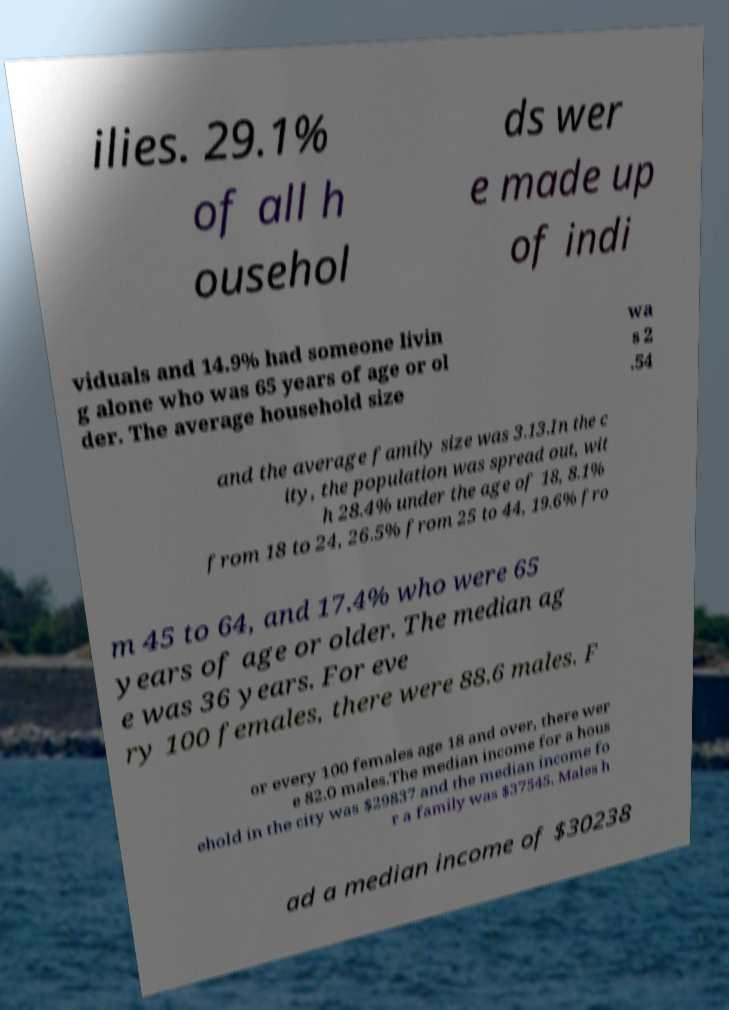What messages or text are displayed in this image? I need them in a readable, typed format. ilies. 29.1% of all h ousehol ds wer e made up of indi viduals and 14.9% had someone livin g alone who was 65 years of age or ol der. The average household size wa s 2 .54 and the average family size was 3.13.In the c ity, the population was spread out, wit h 28.4% under the age of 18, 8.1% from 18 to 24, 26.5% from 25 to 44, 19.6% fro m 45 to 64, and 17.4% who were 65 years of age or older. The median ag e was 36 years. For eve ry 100 females, there were 88.6 males. F or every 100 females age 18 and over, there wer e 82.0 males.The median income for a hous ehold in the city was $29837 and the median income fo r a family was $37545. Males h ad a median income of $30238 